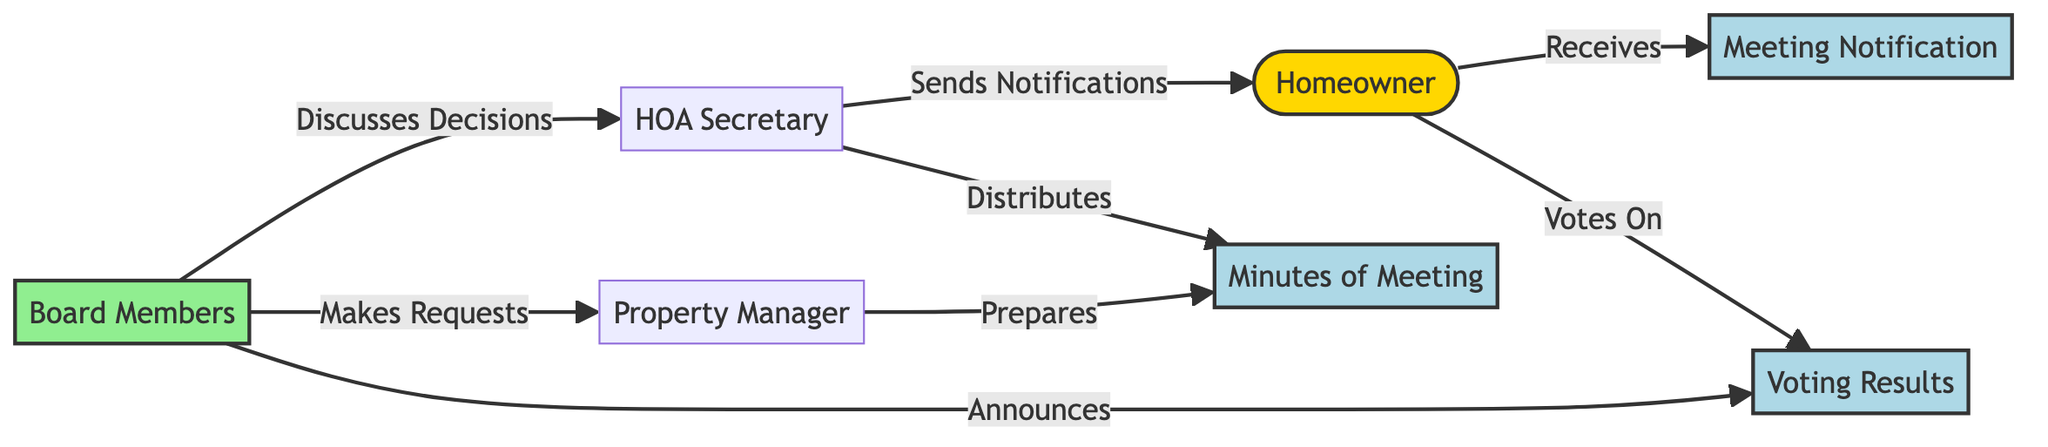What entity sends notifications to the homeowners? The diagram shows an edge connecting the HOA Secretary to the Homeowner with the label "Sends Notifications". This indicates that the HOA Secretary is responsible for sending notifications to homeowners.
Answer: HOA Secretary How many edges are present in the diagram? By counting the lines that connect the nodes, there are a total of 8 edges including all communications and decisions represented.
Answer: 8 Who prepares the minutes of the meeting? The edge from the Property Manager to Minutes of Meeting with the label "Prepares" indicates that the Property Manager is responsible for preparing the minutes of the meeting.
Answer: Property Manager What do homeowners receive regarding meetings? The diagram indicates that homeowners receive meeting notifications, as shown by the edge titled "Receives" leading from the Homeowner to the Meeting Notification node.
Answer: Meeting Notification Which group discusses decisions with the HOA Secretary? The diagram shows that the Board Members discuss decisions with the HOA Secretary, as indicated by the edge labeled "Discusses Decisions". This shows the collaborative nature between the board and the HOA Secretary for decision-making.
Answer: Board Members What documents are distributed by the HOA Secretary? An edge in the diagram connects the HOA Secretary to Minutes of Meeting labeled "Distributes". This indicates that the HOA Secretary is responsible for distributing the minutes of the meeting to homeowners or relevant parties.
Answer: Minutes of Meeting Who announces the voting results? The diagram shows that the Board Members are the ones who announce the voting results, as illustrated by the edge linking Board Members to Voting Results with the label "Announces".
Answer: Board Members How many different roles are visually represented in this communication flow? Counting all the distinct nodes in the diagram reveals there are 7 different roles or entities participating in the communication process, including homeowners and various officials.
Answer: 7 